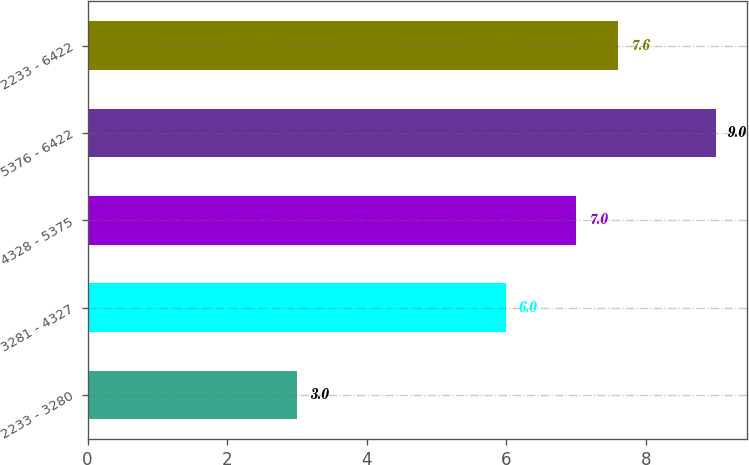Convert chart to OTSL. <chart><loc_0><loc_0><loc_500><loc_500><bar_chart><fcel>2233 - 3280<fcel>3281 - 4327<fcel>4328 - 5375<fcel>5376 - 6422<fcel>2233 - 6422<nl><fcel>3<fcel>6<fcel>7<fcel>9<fcel>7.6<nl></chart> 